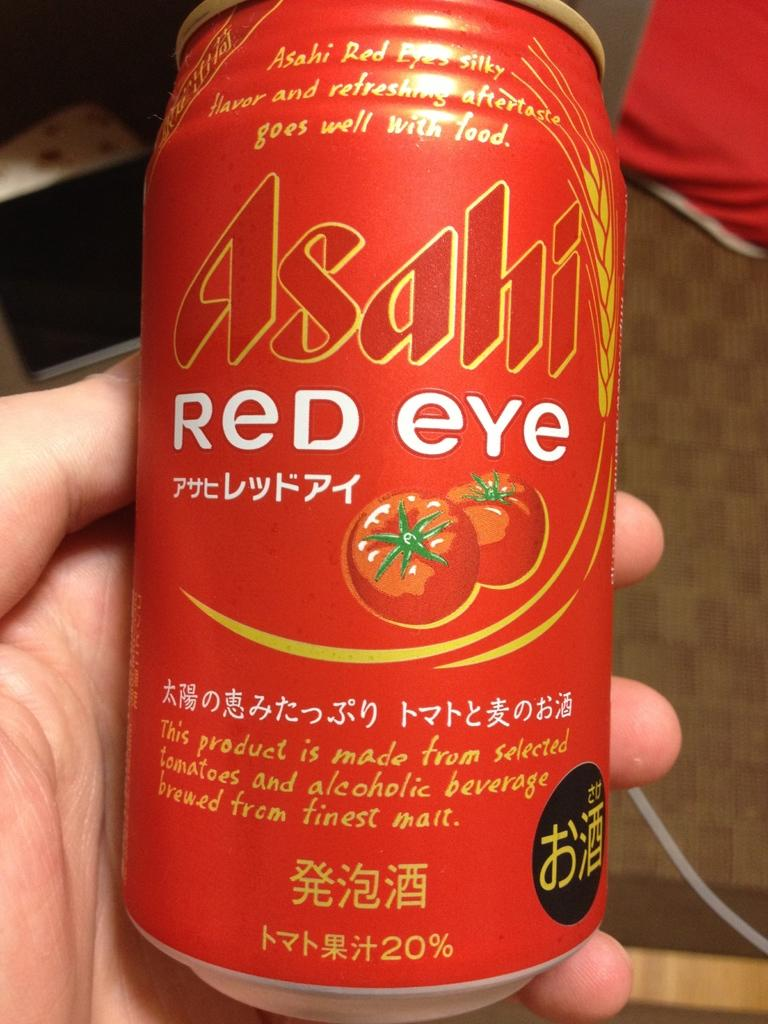<image>
Offer a succinct explanation of the picture presented. A hand holds a can of Asahi Red Eye that has a picture of tomatoes on it. 